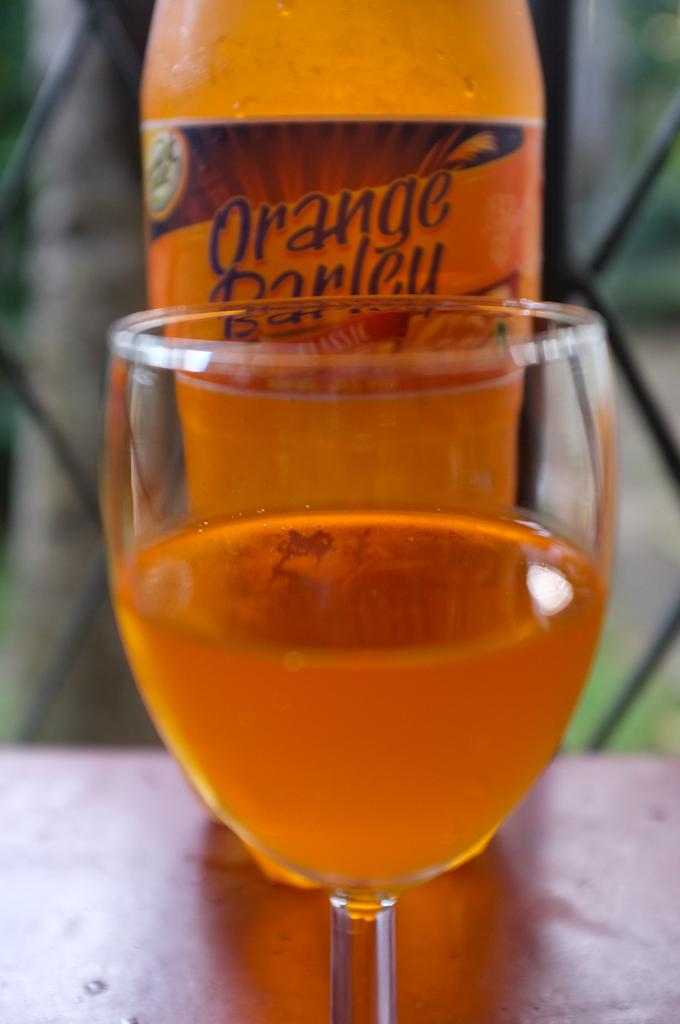<image>
Create a compact narrative representing the image presented. A glass of orange liquid is in a glass in front of a bottled labeled Orange Barley. 